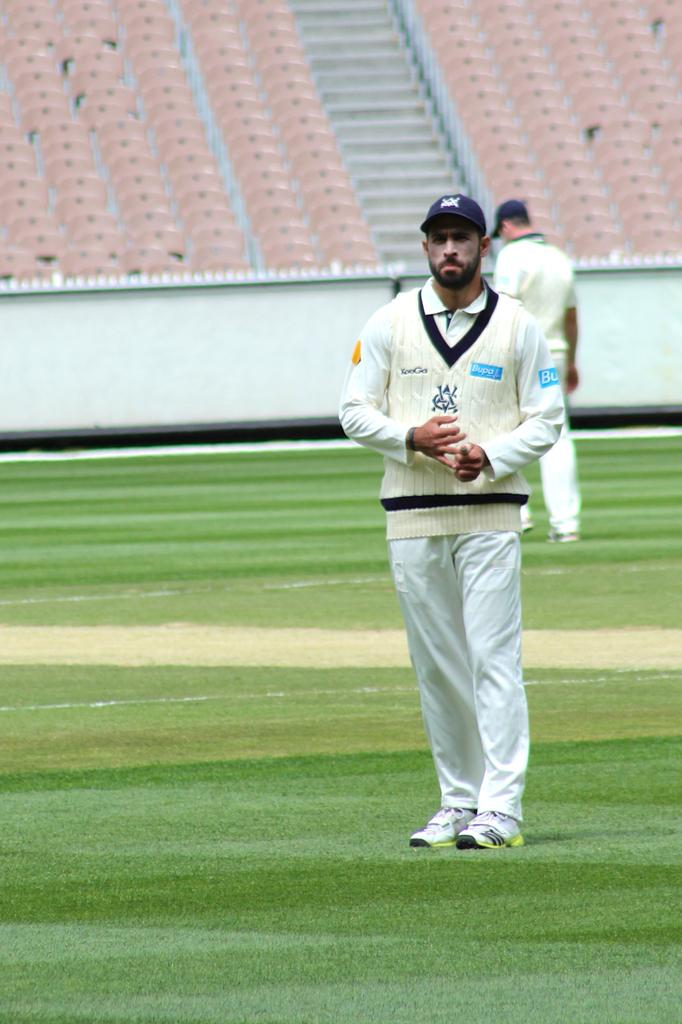<image>
Offer a succinct explanation of the picture presented. A man in a cream sweater that says Bupa in a blue color 